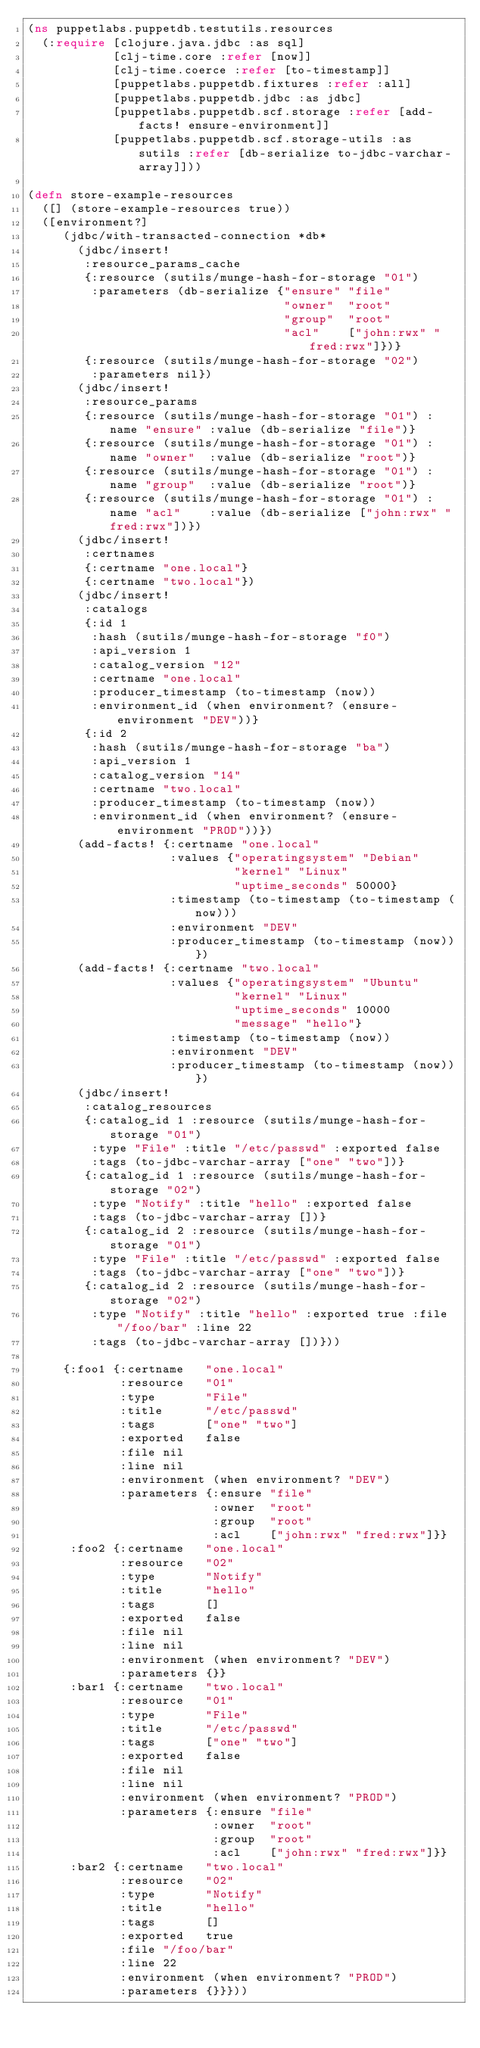<code> <loc_0><loc_0><loc_500><loc_500><_Clojure_>(ns puppetlabs.puppetdb.testutils.resources
  (:require [clojure.java.jdbc :as sql]
            [clj-time.core :refer [now]]
            [clj-time.coerce :refer [to-timestamp]]
            [puppetlabs.puppetdb.fixtures :refer :all]
            [puppetlabs.puppetdb.jdbc :as jdbc]
            [puppetlabs.puppetdb.scf.storage :refer [add-facts! ensure-environment]]
            [puppetlabs.puppetdb.scf.storage-utils :as sutils :refer [db-serialize to-jdbc-varchar-array]]))

(defn store-example-resources
  ([] (store-example-resources true))
  ([environment?]
     (jdbc/with-transacted-connection *db*
       (jdbc/insert!
        :resource_params_cache
        {:resource (sutils/munge-hash-for-storage "01")
         :parameters (db-serialize {"ensure" "file"
                                    "owner"  "root"
                                    "group"  "root"
                                    "acl"    ["john:rwx" "fred:rwx"]})}
        {:resource (sutils/munge-hash-for-storage "02")
         :parameters nil})
       (jdbc/insert!
        :resource_params
        {:resource (sutils/munge-hash-for-storage "01") :name "ensure" :value (db-serialize "file")}
        {:resource (sutils/munge-hash-for-storage "01") :name "owner"  :value (db-serialize "root")}
        {:resource (sutils/munge-hash-for-storage "01") :name "group"  :value (db-serialize "root")}
        {:resource (sutils/munge-hash-for-storage "01") :name "acl"    :value (db-serialize ["john:rwx" "fred:rwx"])})
       (jdbc/insert!
        :certnames
        {:certname "one.local"}
        {:certname "two.local"})
       (jdbc/insert!
        :catalogs
        {:id 1
         :hash (sutils/munge-hash-for-storage "f0")
         :api_version 1
         :catalog_version "12"
         :certname "one.local"
         :producer_timestamp (to-timestamp (now))
         :environment_id (when environment? (ensure-environment "DEV"))}
        {:id 2
         :hash (sutils/munge-hash-for-storage "ba")
         :api_version 1
         :catalog_version "14"
         :certname "two.local"
         :producer_timestamp (to-timestamp (now))
         :environment_id (when environment? (ensure-environment "PROD"))})
       (add-facts! {:certname "one.local"
                    :values {"operatingsystem" "Debian"
                             "kernel" "Linux"
                             "uptime_seconds" 50000}
                    :timestamp (to-timestamp (to-timestamp (now)))
                    :environment "DEV"
                    :producer_timestamp (to-timestamp (now))})
       (add-facts! {:certname "two.local"
                    :values {"operatingsystem" "Ubuntu"
                             "kernel" "Linux"
                             "uptime_seconds" 10000
                             "message" "hello"}
                    :timestamp (to-timestamp (now))
                    :environment "DEV"
                    :producer_timestamp (to-timestamp (now))})
       (jdbc/insert!
        :catalog_resources
        {:catalog_id 1 :resource (sutils/munge-hash-for-storage "01")
         :type "File" :title "/etc/passwd" :exported false
         :tags (to-jdbc-varchar-array ["one" "two"])}
        {:catalog_id 1 :resource (sutils/munge-hash-for-storage "02")
         :type "Notify" :title "hello" :exported false
         :tags (to-jdbc-varchar-array [])}
        {:catalog_id 2 :resource (sutils/munge-hash-for-storage "01")
         :type "File" :title "/etc/passwd" :exported false
         :tags (to-jdbc-varchar-array ["one" "two"])}
        {:catalog_id 2 :resource (sutils/munge-hash-for-storage "02")
         :type "Notify" :title "hello" :exported true :file "/foo/bar" :line 22
         :tags (to-jdbc-varchar-array [])}))

     {:foo1 {:certname   "one.local"
             :resource   "01"
             :type       "File"
             :title      "/etc/passwd"
             :tags       ["one" "two"]
             :exported   false
             :file nil
             :line nil
             :environment (when environment? "DEV")
             :parameters {:ensure "file"
                          :owner  "root"
                          :group  "root"
                          :acl    ["john:rwx" "fred:rwx"]}}
      :foo2 {:certname   "one.local"
             :resource   "02"
             :type       "Notify"
             :title      "hello"
             :tags       []
             :exported   false
             :file nil
             :line nil
             :environment (when environment? "DEV")
             :parameters {}}
      :bar1 {:certname   "two.local"
             :resource   "01"
             :type       "File"
             :title      "/etc/passwd"
             :tags       ["one" "two"]
             :exported   false
             :file nil
             :line nil
             :environment (when environment? "PROD")
             :parameters {:ensure "file"
                          :owner  "root"
                          :group  "root"
                          :acl    ["john:rwx" "fred:rwx"]}}
      :bar2 {:certname   "two.local"
             :resource   "02"
             :type       "Notify"
             :title      "hello"
             :tags       []
             :exported   true
             :file "/foo/bar"
             :line 22
             :environment (when environment? "PROD")
             :parameters {}}}))
</code> 